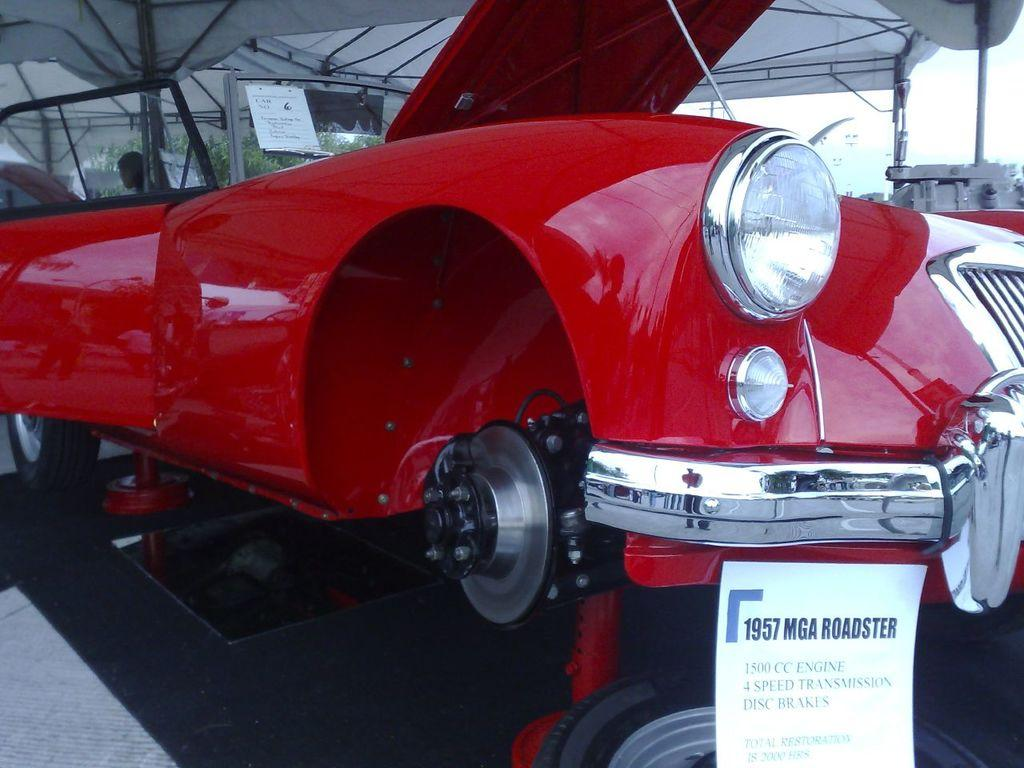What color is the car in the image? The car in the image is red. Where is the car located in the image? The car is placed on the floor. What can be seen at the top of the image? There is a white color tint at the top of the image. Can you describe the presence of a person in the image? There is a person in the background of the image. What type of cherry is being used as a decoration on the car in the image? There is no cherry present in the image, and therefore no such decoration can be observed. 